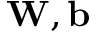<formula> <loc_0><loc_0><loc_500><loc_500>W , b</formula> 